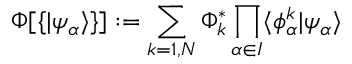Convert formula to latex. <formula><loc_0><loc_0><loc_500><loc_500>\Phi [ \{ | \psi _ { \alpha } \rangle \} ] \colon = \sum _ { k = 1 , N } \Phi _ { k } ^ { * } \prod _ { \alpha \in I } \langle \phi _ { \alpha } ^ { k } | \psi _ { \alpha } \rangle</formula> 